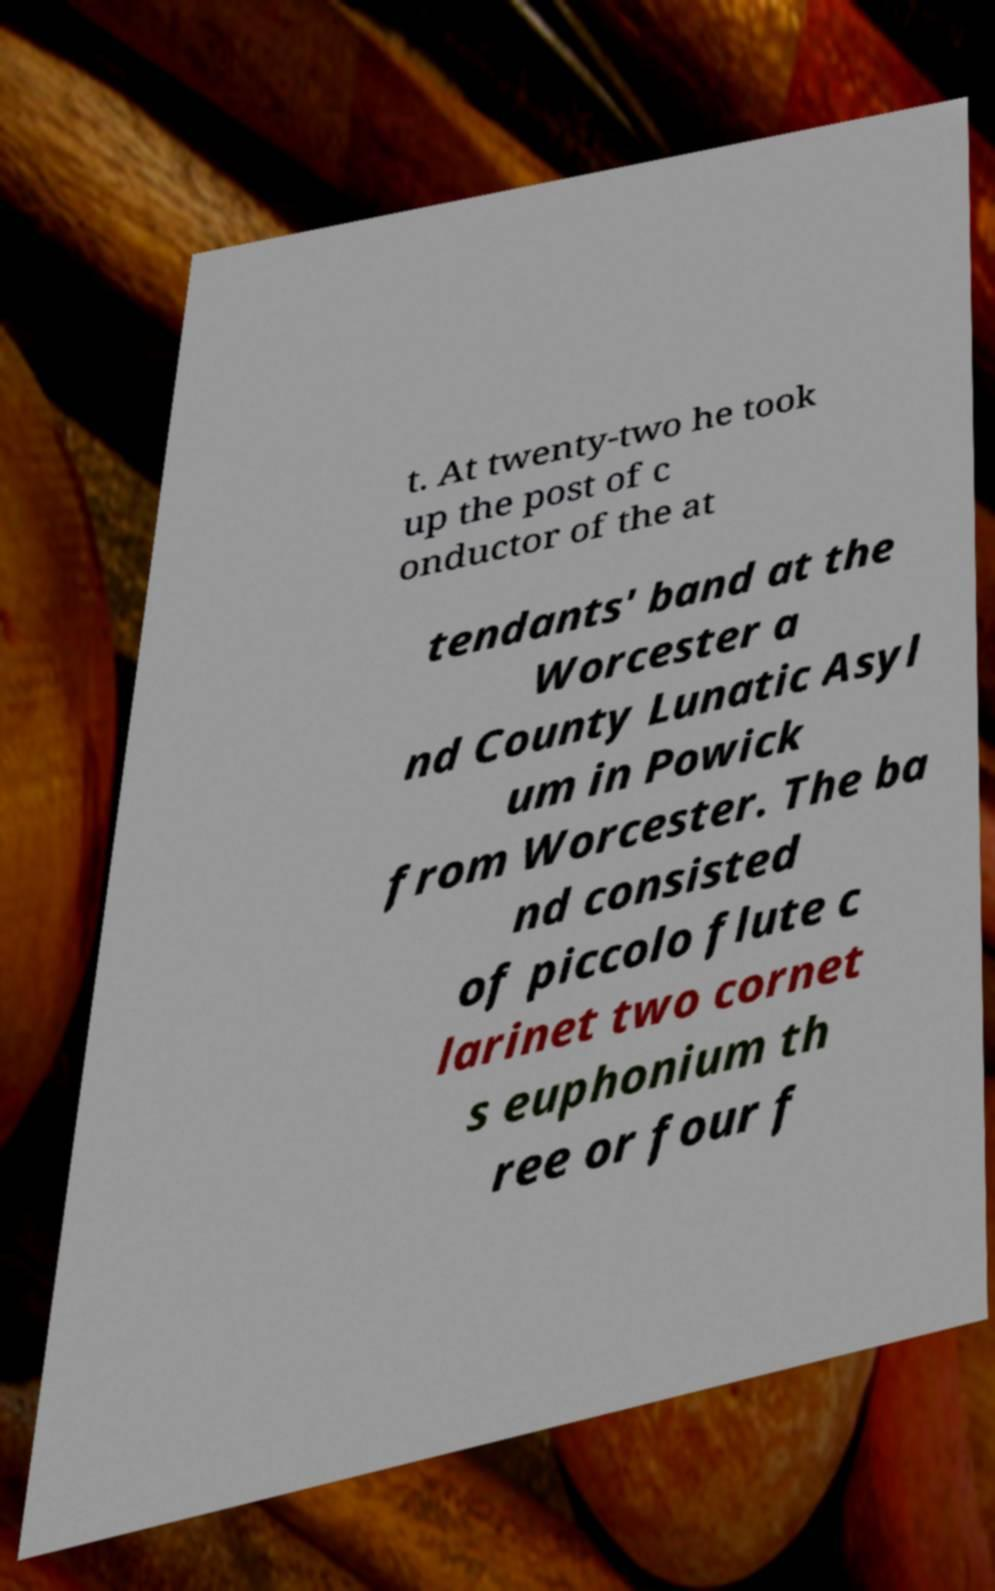Can you read and provide the text displayed in the image?This photo seems to have some interesting text. Can you extract and type it out for me? t. At twenty-two he took up the post of c onductor of the at tendants' band at the Worcester a nd County Lunatic Asyl um in Powick from Worcester. The ba nd consisted of piccolo flute c larinet two cornet s euphonium th ree or four f 